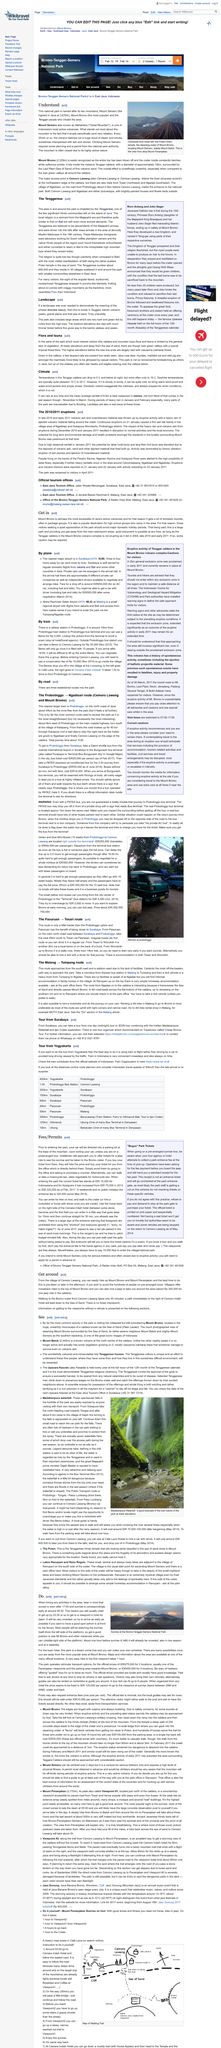Mention a couple of crucial points in this snapshot. The best time to hike up Mount Bromo and Mount Penanjakan is either pre-dawn or later in the afternoon. Indonesian travel speeds are generally 30 km/h. Visiting Mount Bromo is the most common activity in the park and is widely considered to be the most notable attraction. On January 21st, 2011, the eruptions of Mount Merapi caused ash to fall mainly in the villages of Ngadirejo and Sukapura Wonokerto, located in the Probolinggo district. The ashfall affected these areas due to the eruption of the volcano. Villagers offer horseback rides to the top of Mount Bromo as a means of traveling to the summit. 